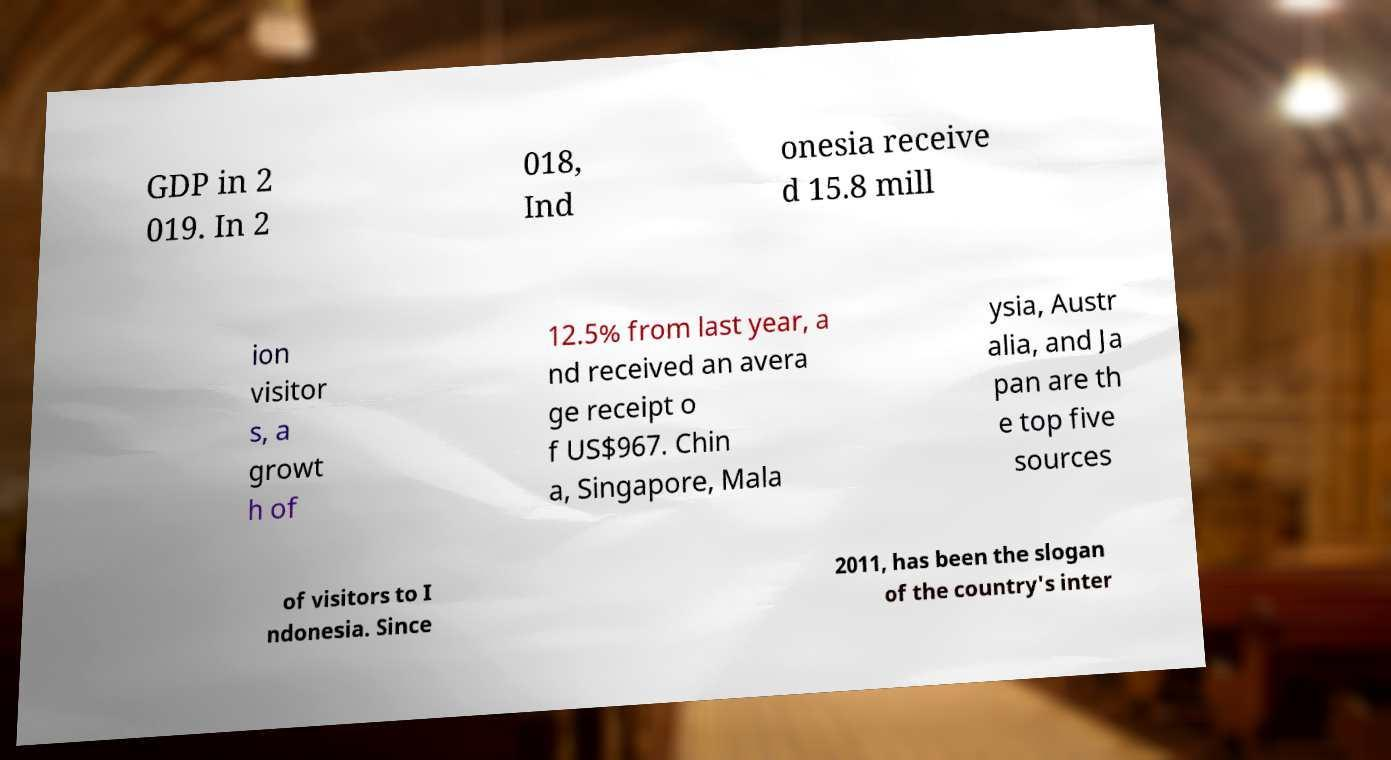Can you read and provide the text displayed in the image?This photo seems to have some interesting text. Can you extract and type it out for me? GDP in 2 019. In 2 018, Ind onesia receive d 15.8 mill ion visitor s, a growt h of 12.5% from last year, a nd received an avera ge receipt o f US$967. Chin a, Singapore, Mala ysia, Austr alia, and Ja pan are th e top five sources of visitors to I ndonesia. Since 2011, has been the slogan of the country's inter 